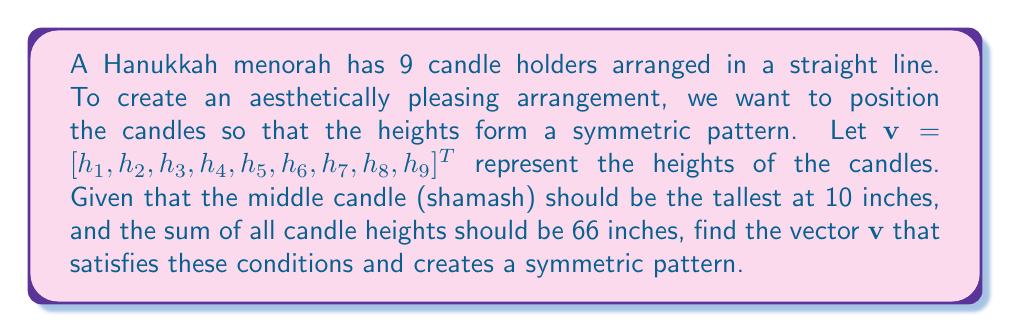Show me your answer to this math problem. Let's approach this step-by-step:

1) First, we know that the middle candle (5th position) should be 10 inches tall:
   $h_5 = 10$

2) For symmetry, we can assume:
   $h_1 = h_9$, $h_2 = h_8$, $h_3 = h_7$, $h_4 = h_6$

3) Let's define variables:
   $h_1 = h_9 = a$
   $h_2 = h_8 = b$
   $h_3 = h_7 = c$
   $h_4 = h_6 = d$

4) Now our vector looks like:
   $\mathbf{v} = [a, b, c, d, 10, d, c, b, a]^T$

5) We know the sum of all heights is 66 inches:
   $2a + 2b + 2c + 2d + 10 = 66$
   $2(a + b + c + d) = 56$
   $a + b + c + d = 28$

6) To create an aesthetically pleasing arrangement, let's make the heights increase linearly from the ends to the middle. This means:
   $b = a + x$
   $c = b + x = a + 2x$
   $d = c + x = a + 3x$

7) Substituting these into our sum equation:
   $a + (a + x) + (a + 2x) + (a + 3x) = 28$
   $4a + 6x = 28$

8) We need another equation to solve for $a$ and $x$. Let's use the fact that $d$ should be 1 inch shorter than the middle candle:
   $a + 3x = 9$

9) Now we have a system of two equations:
   $4a + 6x = 28$
   $a + 3x = 9$

10) Solving this system:
    $x = 2$, $a = 3$

11) Therefore:
    $a = 3$, $b = 5$, $c = 7$, $d = 9$

12) Our final vector is:
    $\mathbf{v} = [3, 5, 7, 9, 10, 9, 7, 5, 3]^T$
Answer: $\mathbf{v} = [3, 5, 7, 9, 10, 9, 7, 5, 3]^T$ 